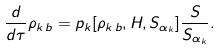Convert formula to latex. <formula><loc_0><loc_0><loc_500><loc_500>\frac { d } { d \tau } \rho _ { k \, b } = p _ { k } [ \rho _ { k \, b } , H , S _ { \alpha _ { k } } ] \frac { S } { S _ { \alpha _ { k } } } .</formula> 